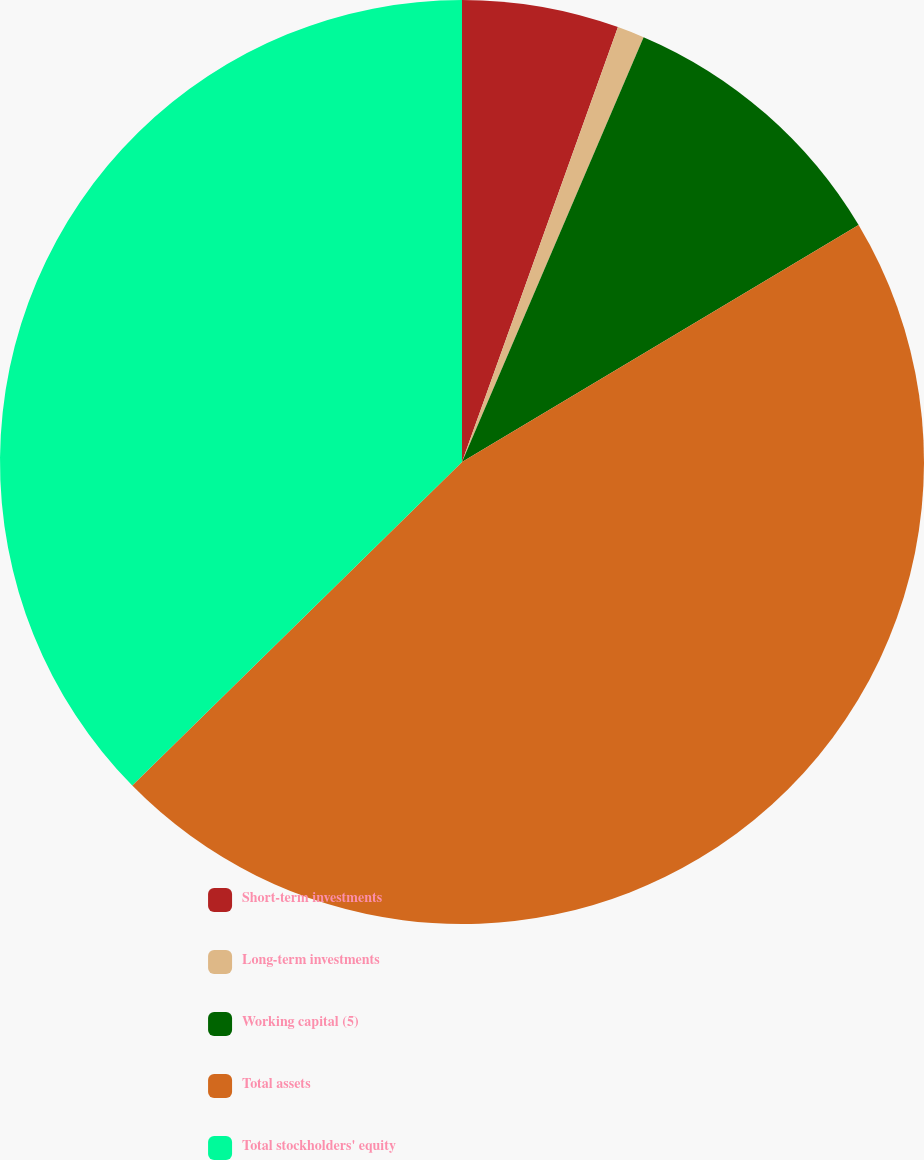Convert chart to OTSL. <chart><loc_0><loc_0><loc_500><loc_500><pie_chart><fcel>Short-term investments<fcel>Long-term investments<fcel>Working capital (5)<fcel>Total assets<fcel>Total stockholders' equity<nl><fcel>5.48%<fcel>0.95%<fcel>10.0%<fcel>46.22%<fcel>37.35%<nl></chart> 